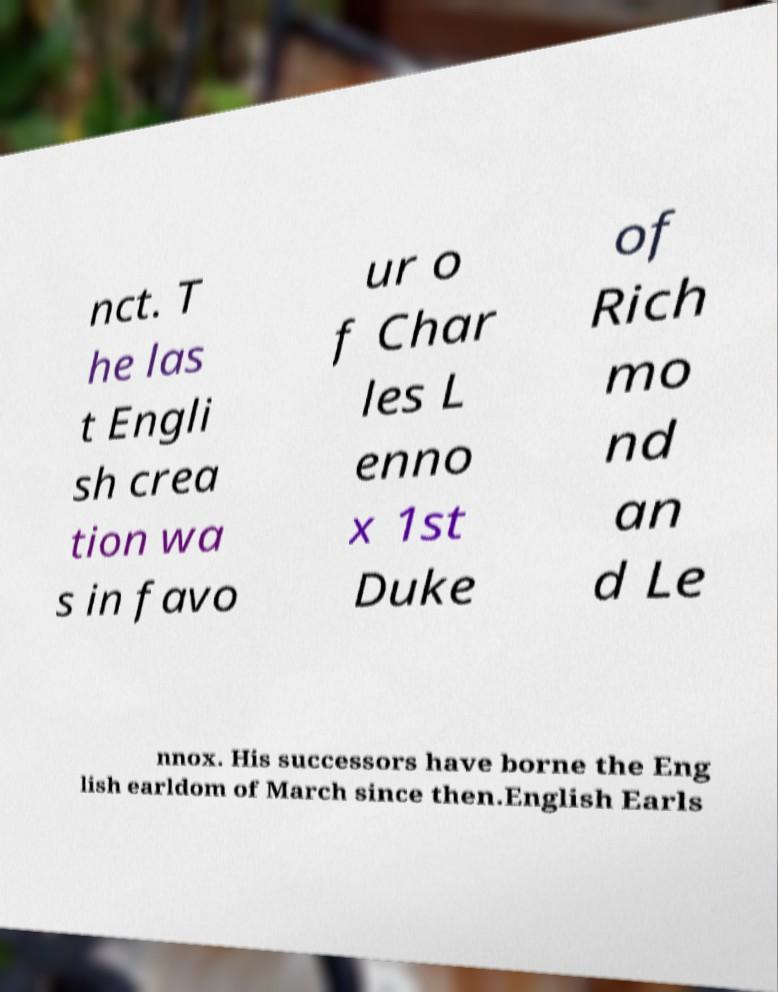What messages or text are displayed in this image? I need them in a readable, typed format. nct. T he las t Engli sh crea tion wa s in favo ur o f Char les L enno x 1st Duke of Rich mo nd an d Le nnox. His successors have borne the Eng lish earldom of March since then.English Earls 